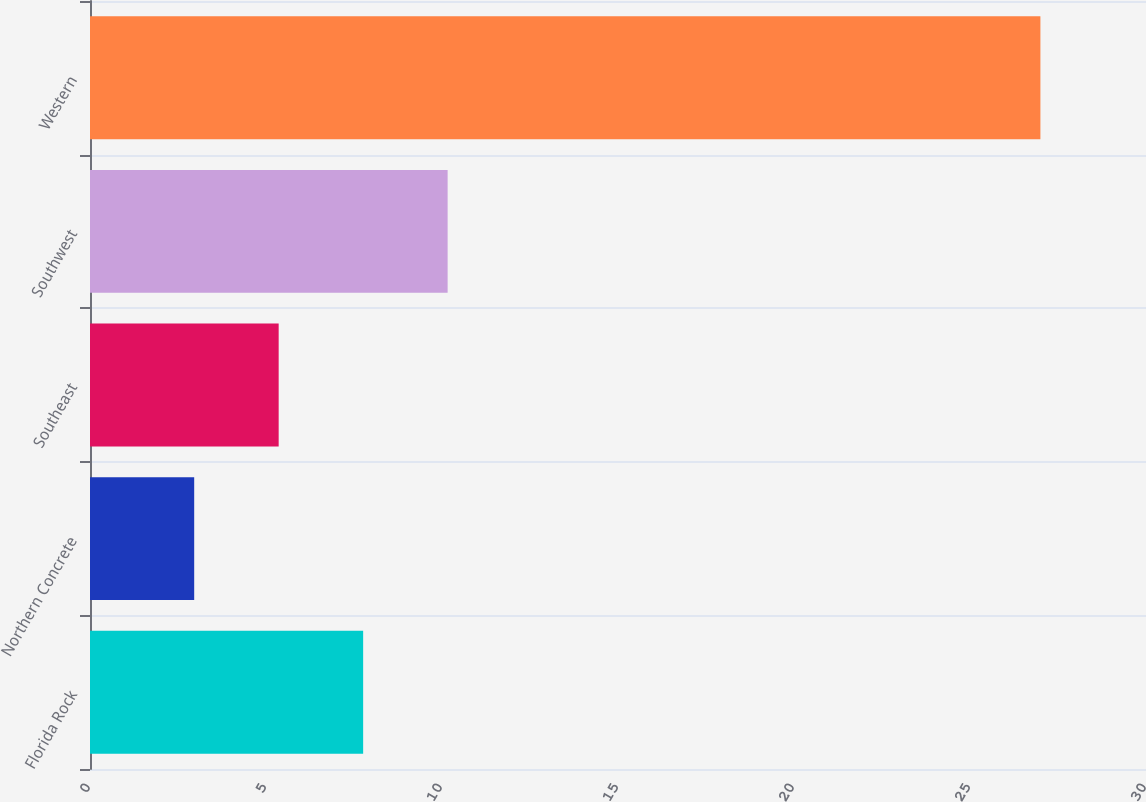Convert chart. <chart><loc_0><loc_0><loc_500><loc_500><bar_chart><fcel>Florida Rock<fcel>Northern Concrete<fcel>Southeast<fcel>Southwest<fcel>Western<nl><fcel>7.76<fcel>2.96<fcel>5.36<fcel>10.16<fcel>27<nl></chart> 